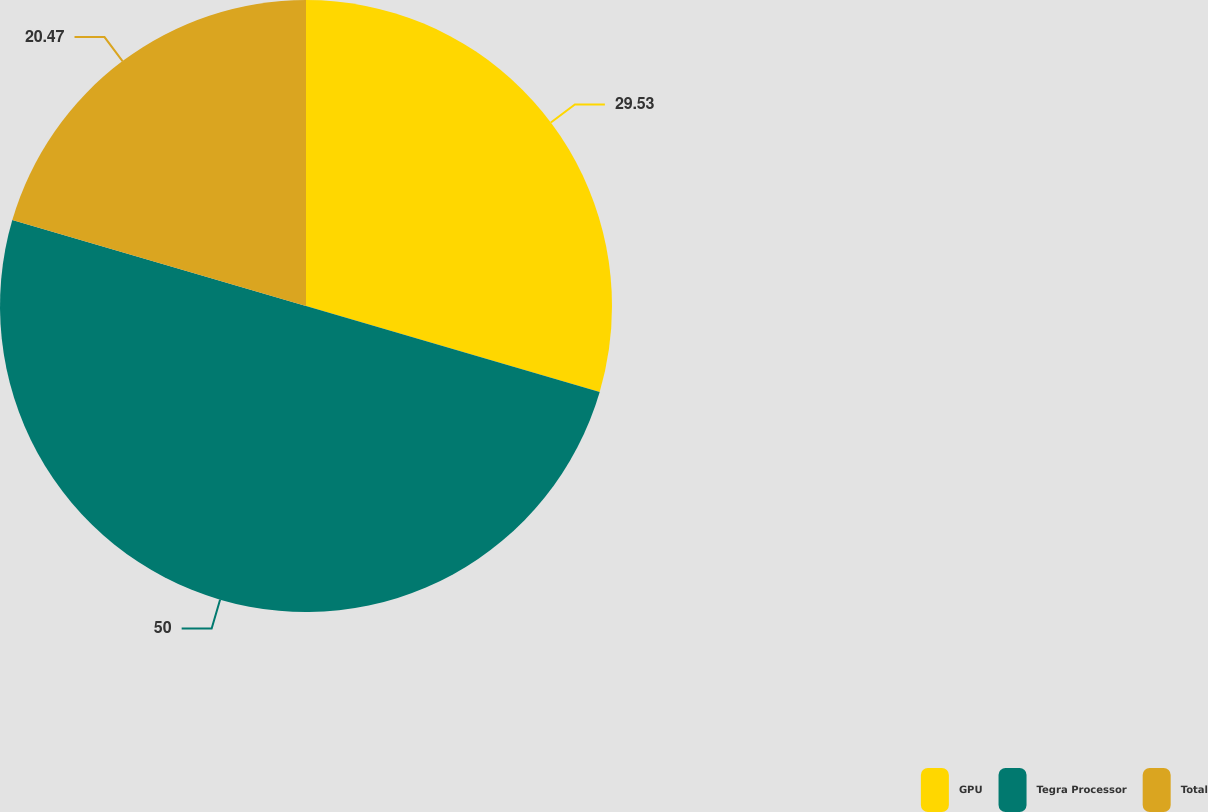Convert chart to OTSL. <chart><loc_0><loc_0><loc_500><loc_500><pie_chart><fcel>GPU<fcel>Tegra Processor<fcel>Total<nl><fcel>29.53%<fcel>50.0%<fcel>20.47%<nl></chart> 